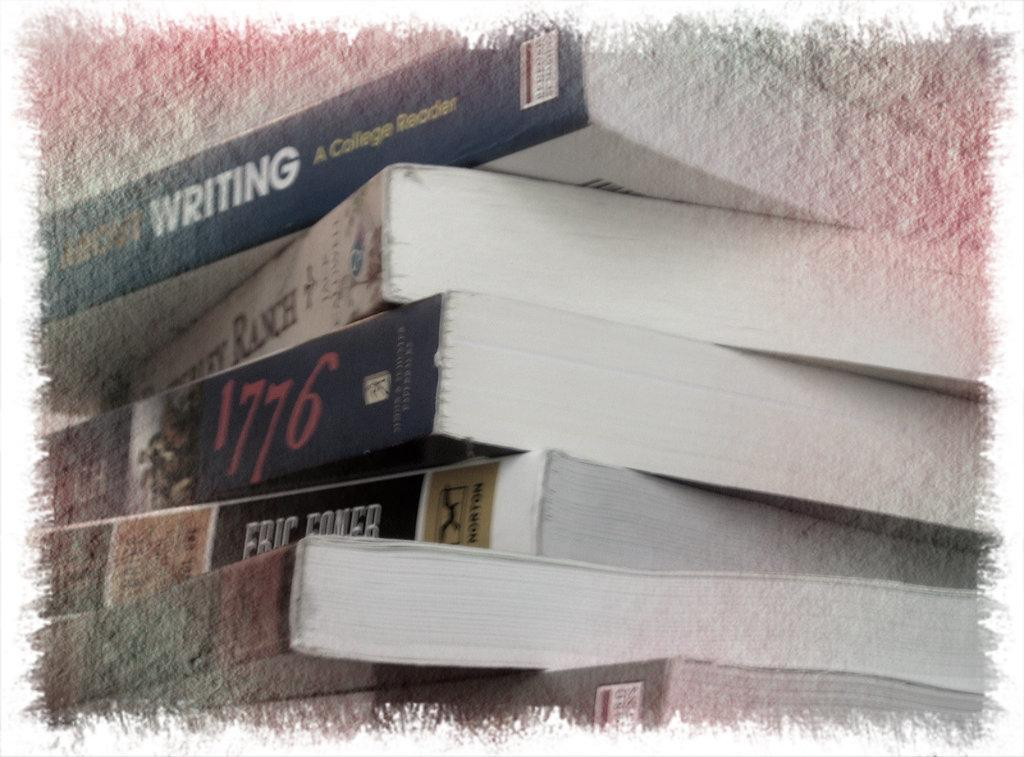<image>
Present a compact description of the photo's key features. a stack of books with the year 1776 on the spine of one of them 